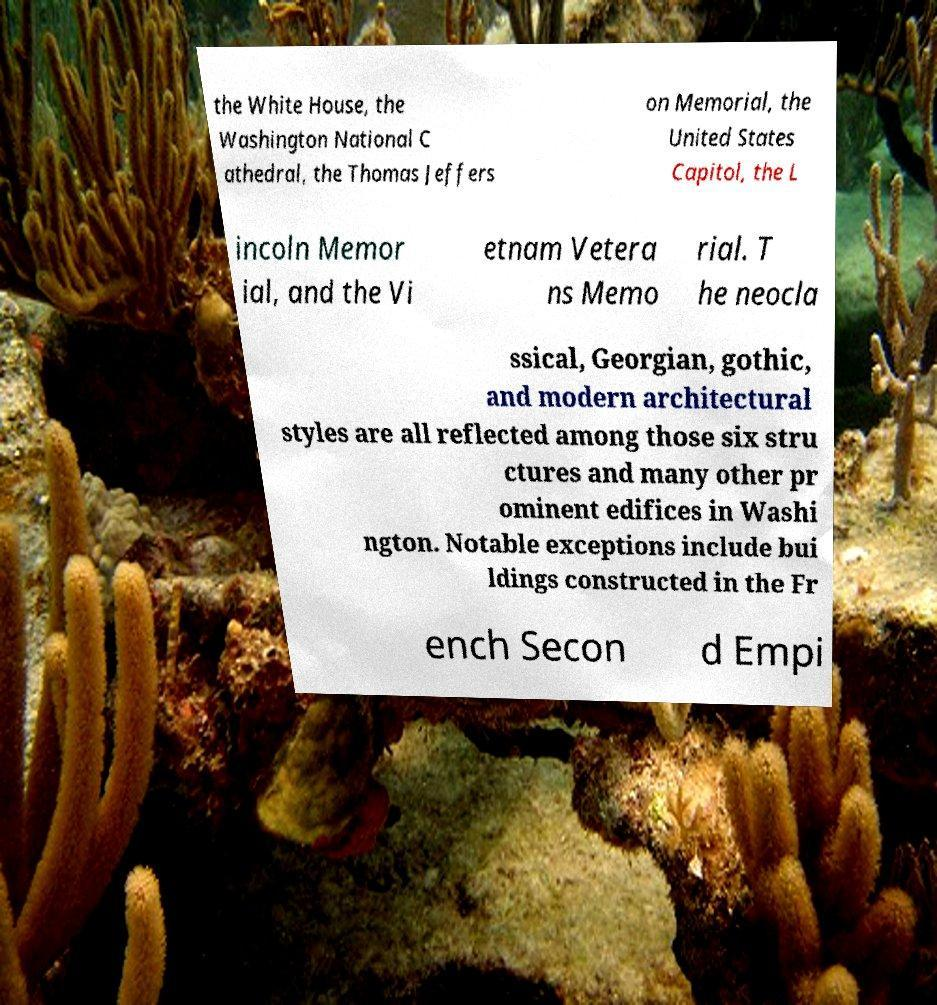Can you read and provide the text displayed in the image?This photo seems to have some interesting text. Can you extract and type it out for me? the White House, the Washington National C athedral, the Thomas Jeffers on Memorial, the United States Capitol, the L incoln Memor ial, and the Vi etnam Vetera ns Memo rial. T he neocla ssical, Georgian, gothic, and modern architectural styles are all reflected among those six stru ctures and many other pr ominent edifices in Washi ngton. Notable exceptions include bui ldings constructed in the Fr ench Secon d Empi 